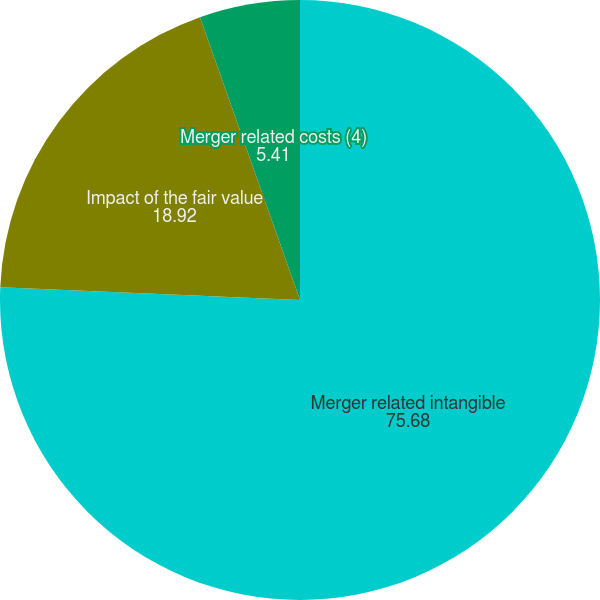Convert chart to OTSL. <chart><loc_0><loc_0><loc_500><loc_500><pie_chart><fcel>Merger related intangible<fcel>Impact of the fair value<fcel>Merger related costs (4)<nl><fcel>75.68%<fcel>18.92%<fcel>5.41%<nl></chart> 